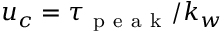Convert formula to latex. <formula><loc_0><loc_0><loc_500><loc_500>u _ { c } = \tau _ { p e a k } / k _ { w }</formula> 